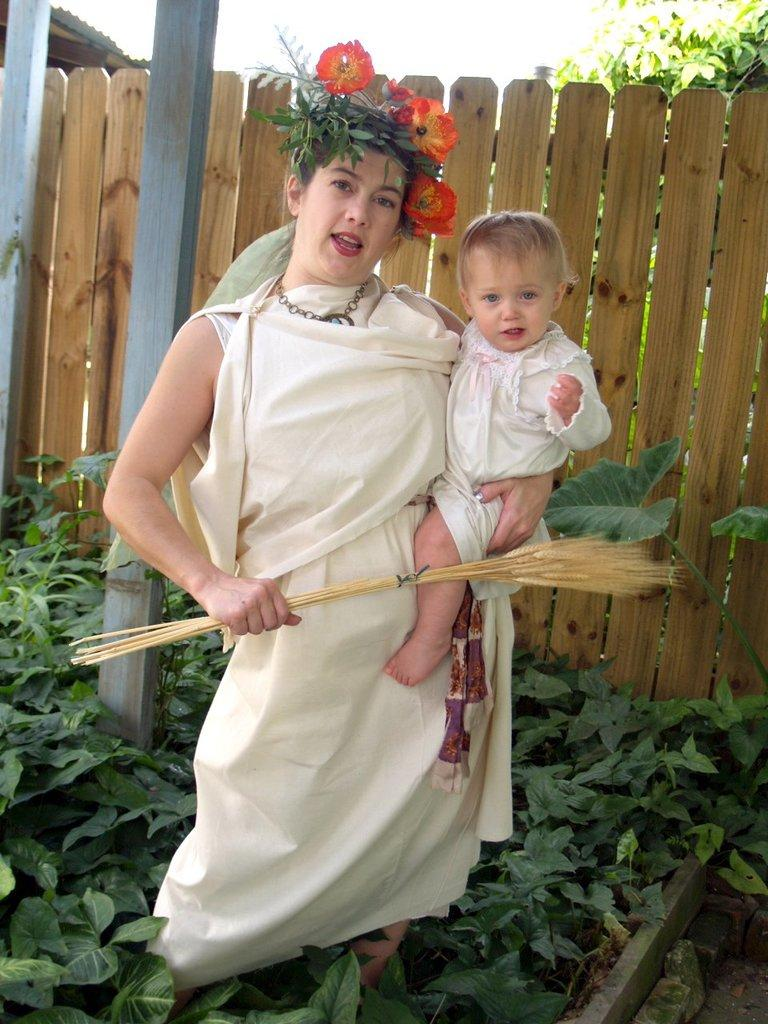Who is the main subject in the image? There is a woman in the image. What is the woman wearing? The woman is wearing a white dress. What is the woman doing in the image? The woman is holding a baby. What type of plants can be seen at the bottom of the image? There are green plants at the bottom of the image. What can be seen in the background of the image? There is a wooden fencing in the background of the image. What type of silk is being used to make the governor's hat in the image? There is no governor or hat present in the image. Can you tell me how many ants are crawling on the woman's dress in the image? There are no ants visible on the woman's dress in the image. 